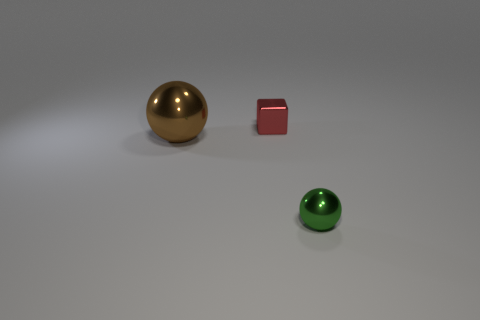Add 3 tiny objects. How many objects exist? 6 Subtract all balls. How many objects are left? 1 Add 3 yellow balls. How many yellow balls exist? 3 Subtract 0 cyan blocks. How many objects are left? 3 Subtract all small cubes. Subtract all brown balls. How many objects are left? 1 Add 1 small shiny objects. How many small shiny objects are left? 3 